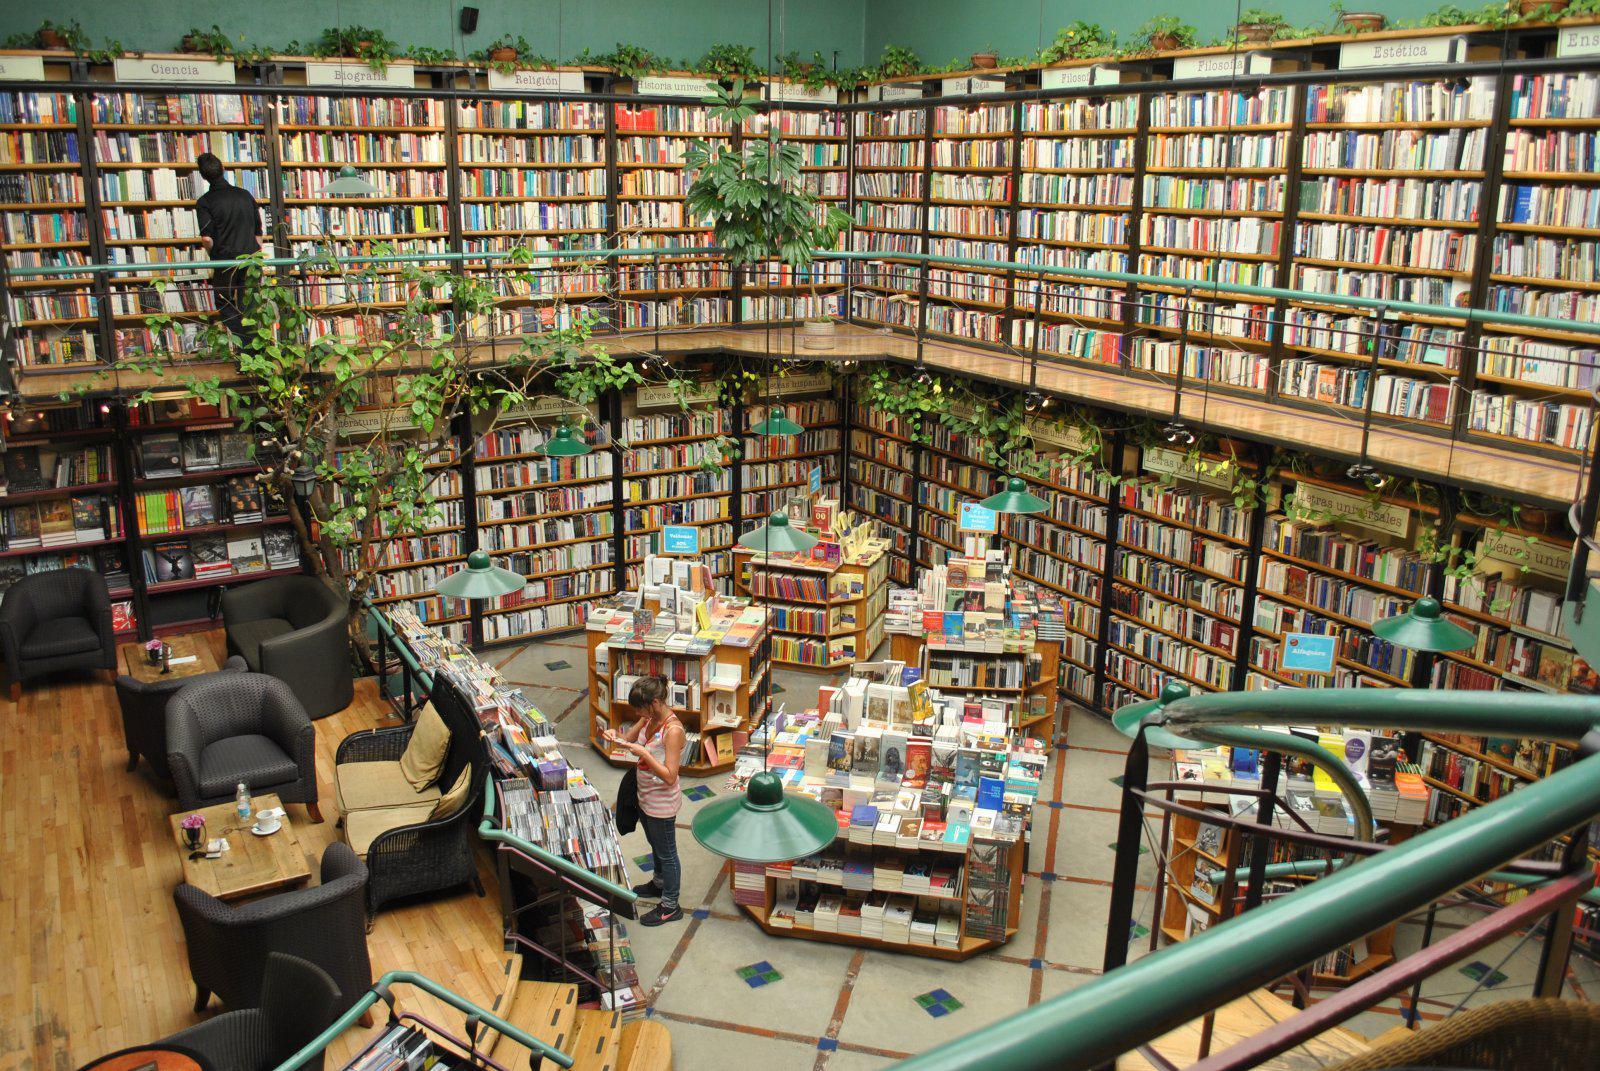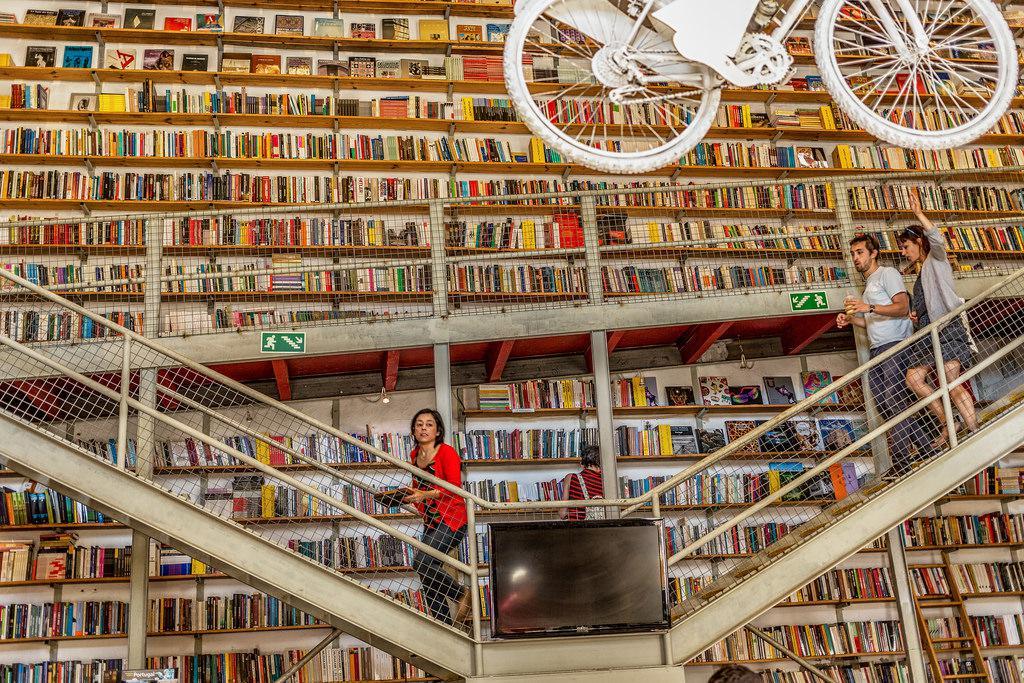The first image is the image on the left, the second image is the image on the right. Assess this claim about the two images: "There is a bicycle hanging from the ceiling.". Correct or not? Answer yes or no. Yes. The first image is the image on the left, the second image is the image on the right. For the images shown, is this caption "One of the images includes a bicycle suspended in the air." true? Answer yes or no. Yes. 